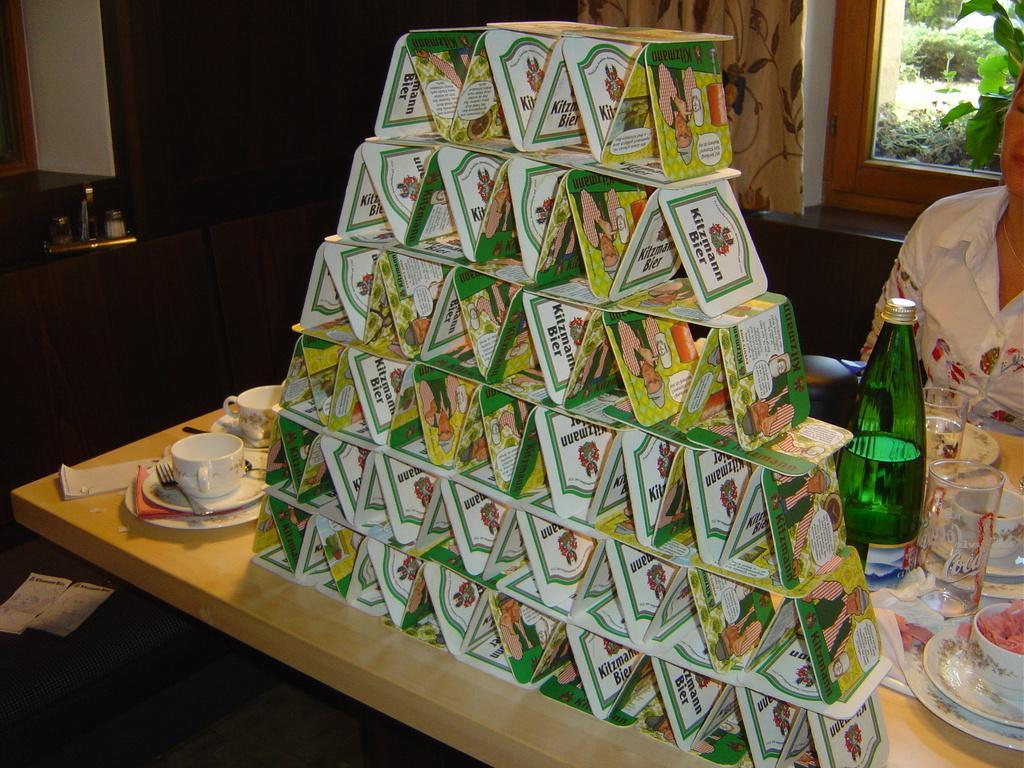Describe this image in one or two sentences. In this image I can see a person. On the table there is a cards,cup,saucer,spoon,fork,tissues,bottle and a glass. The cards are arranged in a row. At the back side there is a window and a trees. There is a brown curtain. 